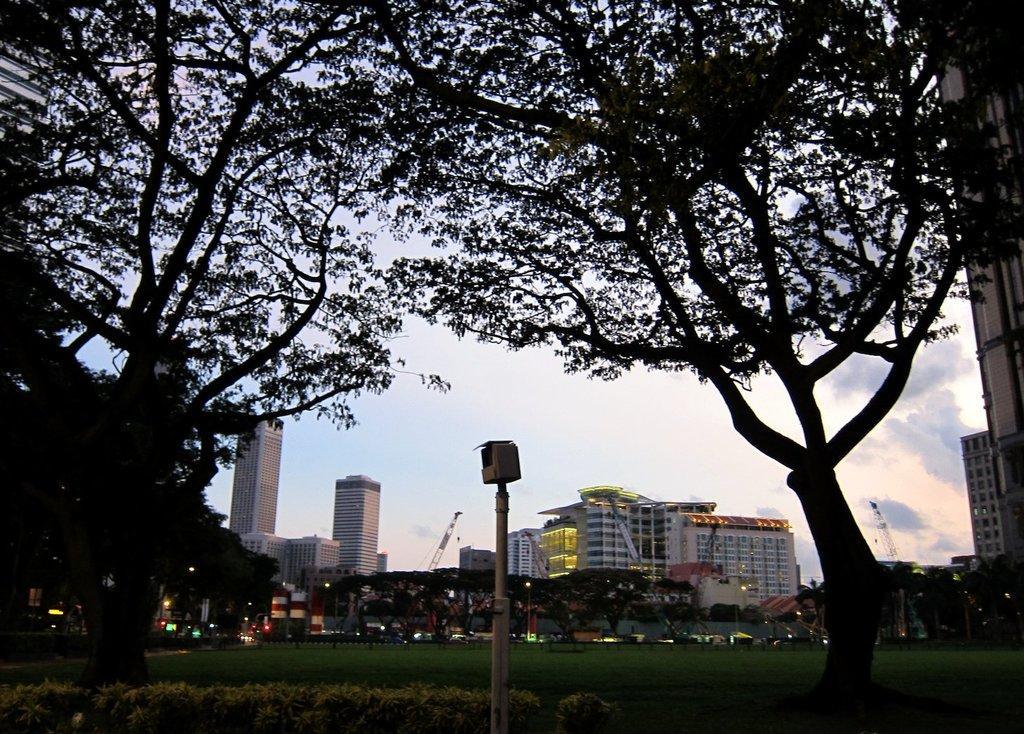Could you give a brief overview of what you see in this image? There is a tree on the left side of this image and on the right side of this image as well. We can see trees, buildings and a pole in the middle of this image and the sky is in the background. 